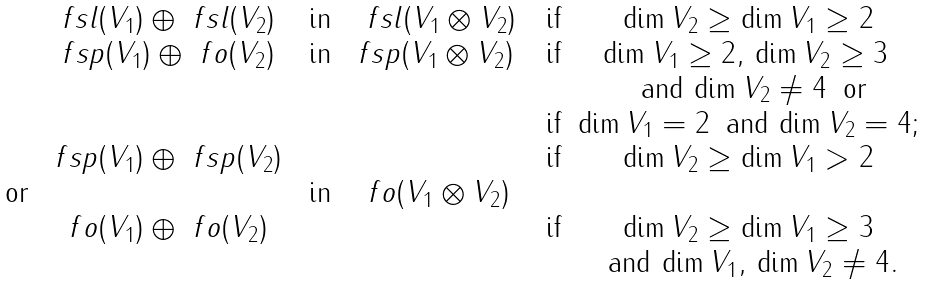<formula> <loc_0><loc_0><loc_500><loc_500>\begin{matrix} & \ f s l ( V _ { 1 } ) \oplus \ f s l ( V _ { 2 } ) & \text { in} & \, \ f s l ( V _ { 1 } \otimes V _ { 2 } ) & \text { if} & \dim V _ { 2 } \geq \dim V _ { 1 } \geq 2 \\ & \ f s p ( V _ { 1 } ) \oplus \ f o ( V _ { 2 } ) & \text { in} & \ f s p ( V _ { 1 } \otimes V _ { 2 } ) \, & \text { if} & \dim V _ { 1 } \geq 2 , \, \dim V _ { 2 } \geq 3 \, \\ & & & & & \text { and} \, \dim V _ { 2 } \neq 4 \, \text { or} \\ & & & & \text { if} & \dim V _ { 1 } = 2 \, \text { and} \, \dim V _ { 2 } = 4 ; \\ & \ f s p ( V _ { 1 } ) \oplus \ f s p ( V _ { 2 } ) & & & \text { if} & \dim V _ { 2 } \geq \dim V _ { 1 } > 2 \\ \text { or} & & \text { in} & \ f o ( V _ { 1 } \otimes V _ { 2 } ) & & \\ & \ f o ( V _ { 1 } ) \oplus \ f o ( V _ { 2 } ) & & & \text { if} & \dim V _ { 2 } \geq \dim V _ { 1 } \geq 3 \\ & & & & & \text { and} \, \dim V _ { 1 } , \, \dim V _ { 2 } \neq 4 . \end{matrix}</formula> 